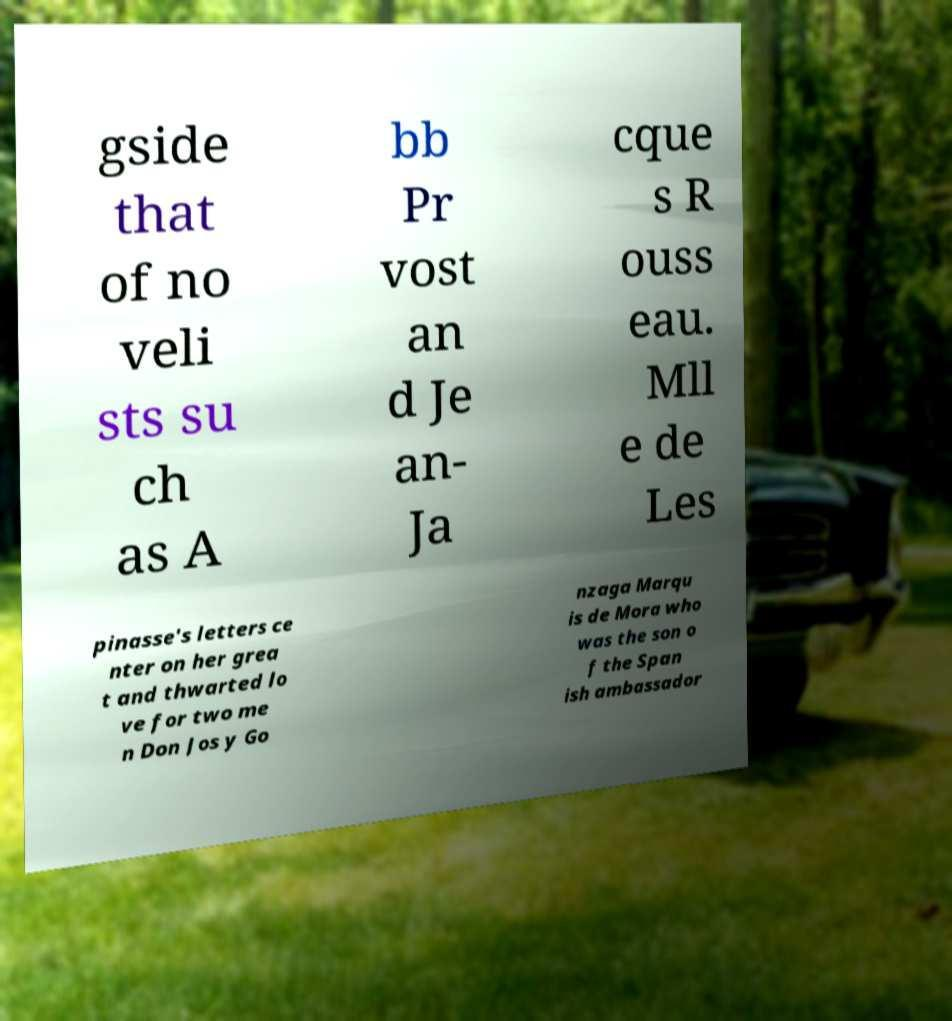What messages or text are displayed in this image? I need them in a readable, typed format. gside that of no veli sts su ch as A bb Pr vost an d Je an- Ja cque s R ouss eau. Mll e de Les pinasse's letters ce nter on her grea t and thwarted lo ve for two me n Don Jos y Go nzaga Marqu is de Mora who was the son o f the Span ish ambassador 